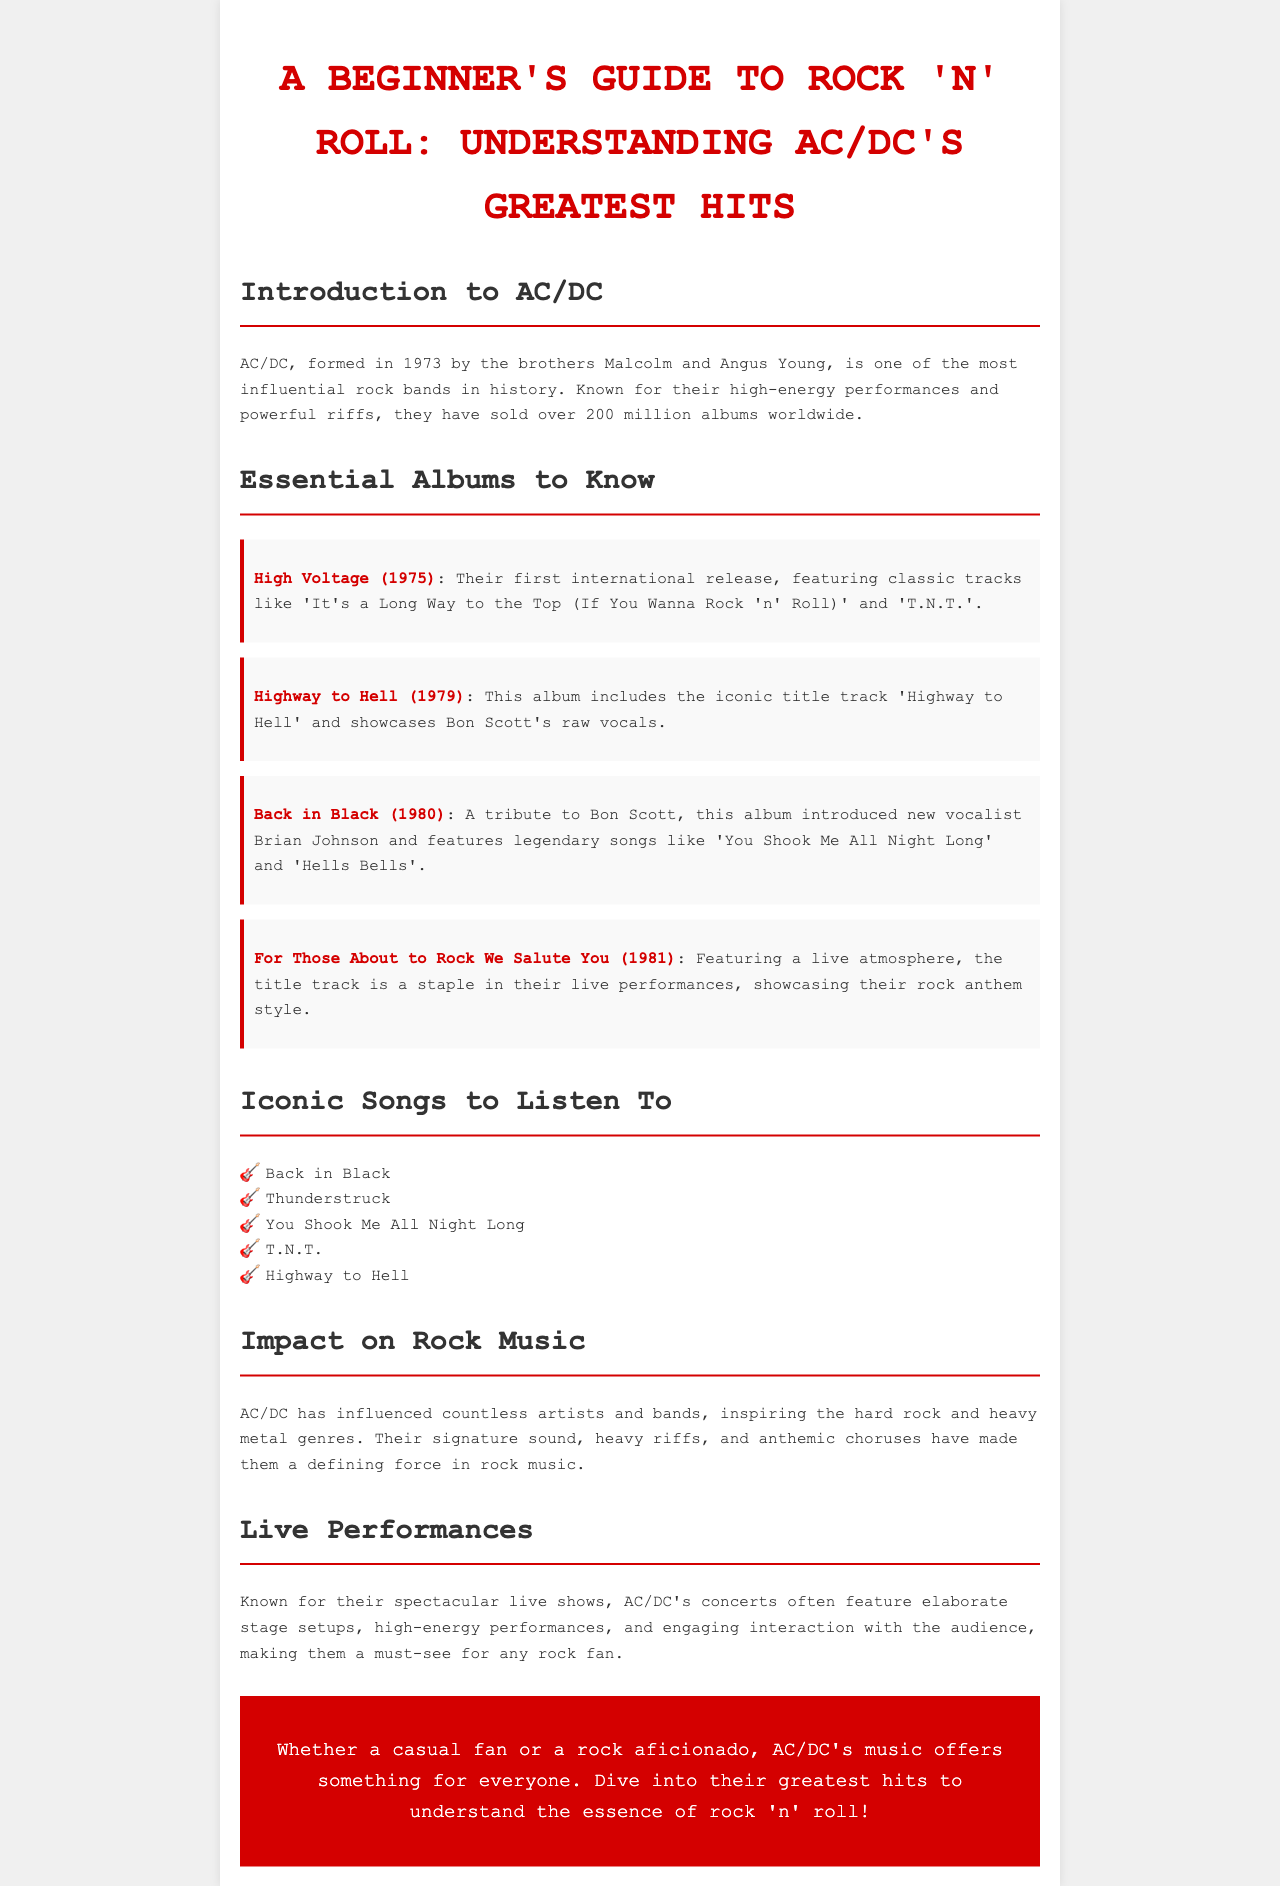What year was AC/DC formed? The document states AC/DC was formed in 1973.
Answer: 1973 What is the title of AC/DC's first international release? According to the document, the first international release is "High Voltage".
Answer: High Voltage Which album features the song 'You Shook Me All Night Long'? The document mentions 'You Shook Me All Night Long' is from the album "Back in Black".
Answer: Back in Black What are AC/DC's concerts known for? The document highlights AC/DC's concerts for their spectacular live shows and high-energy performances.
Answer: Spectacular live shows How many albums are mentioned as essential to know? The document lists four essential albums to know.
Answer: Four Who replaced Bon Scott as the new vocalist? The document states that Brian Johnson is the new vocalist who replaced Bon Scott.
Answer: Brian Johnson What is one impact of AC/DC on music? The document describes that AC/DC has influenced countless artists and bands.
Answer: Countless artists What year was the album "Highway to Hell" released? According to the document, "Highway to Hell" was released in 1979.
Answer: 1979 What is the essence of AC/DC's music described in the conclusion? The document concludes that AC/DC's music offers something for everyone, embodying the essence of rock 'n' roll.
Answer: Essence of rock 'n' roll 